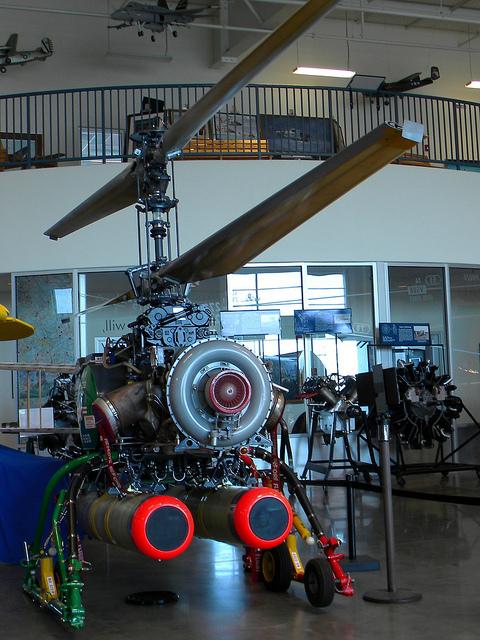How many propellers does the machine have?
Keep it brief. 2. What kind of floor is in the building?
Quick response, please. Tile. Is this a model plane or a real plane?
Answer briefly. Real. What is it?
Short answer required. Helicopter. 